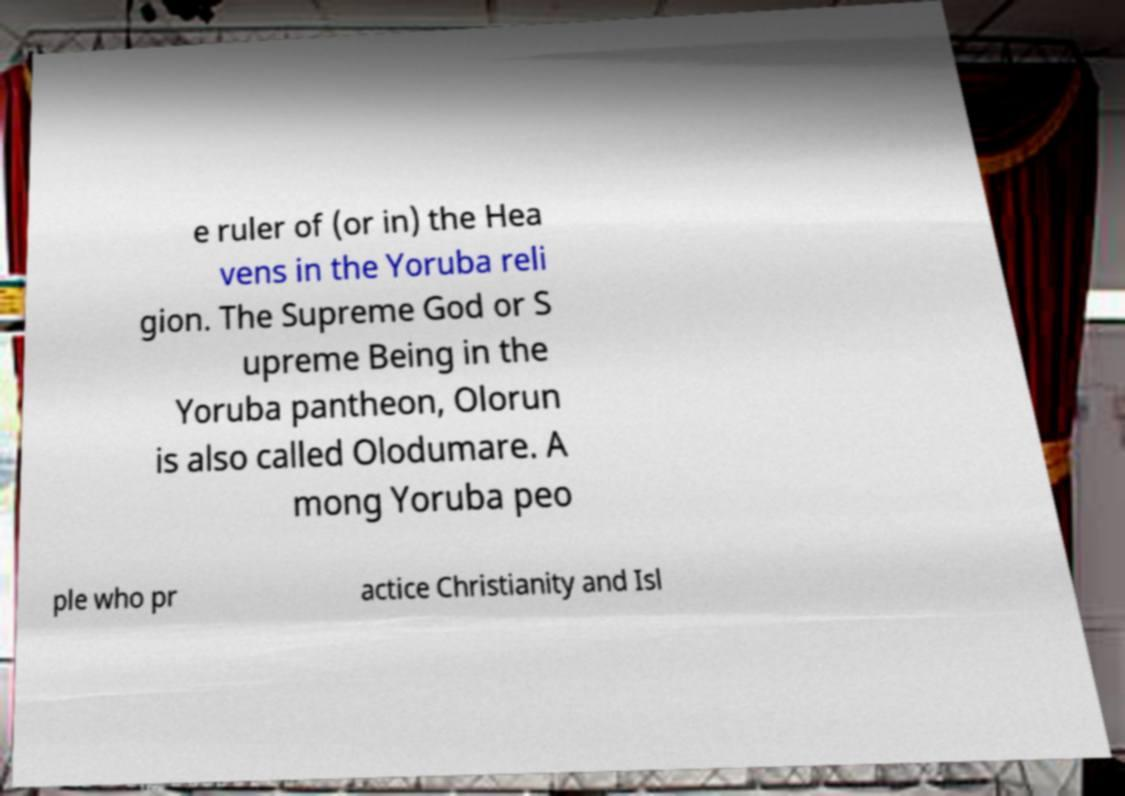There's text embedded in this image that I need extracted. Can you transcribe it verbatim? e ruler of (or in) the Hea vens in the Yoruba reli gion. The Supreme God or S upreme Being in the Yoruba pantheon, Olorun is also called Olodumare. A mong Yoruba peo ple who pr actice Christianity and Isl 